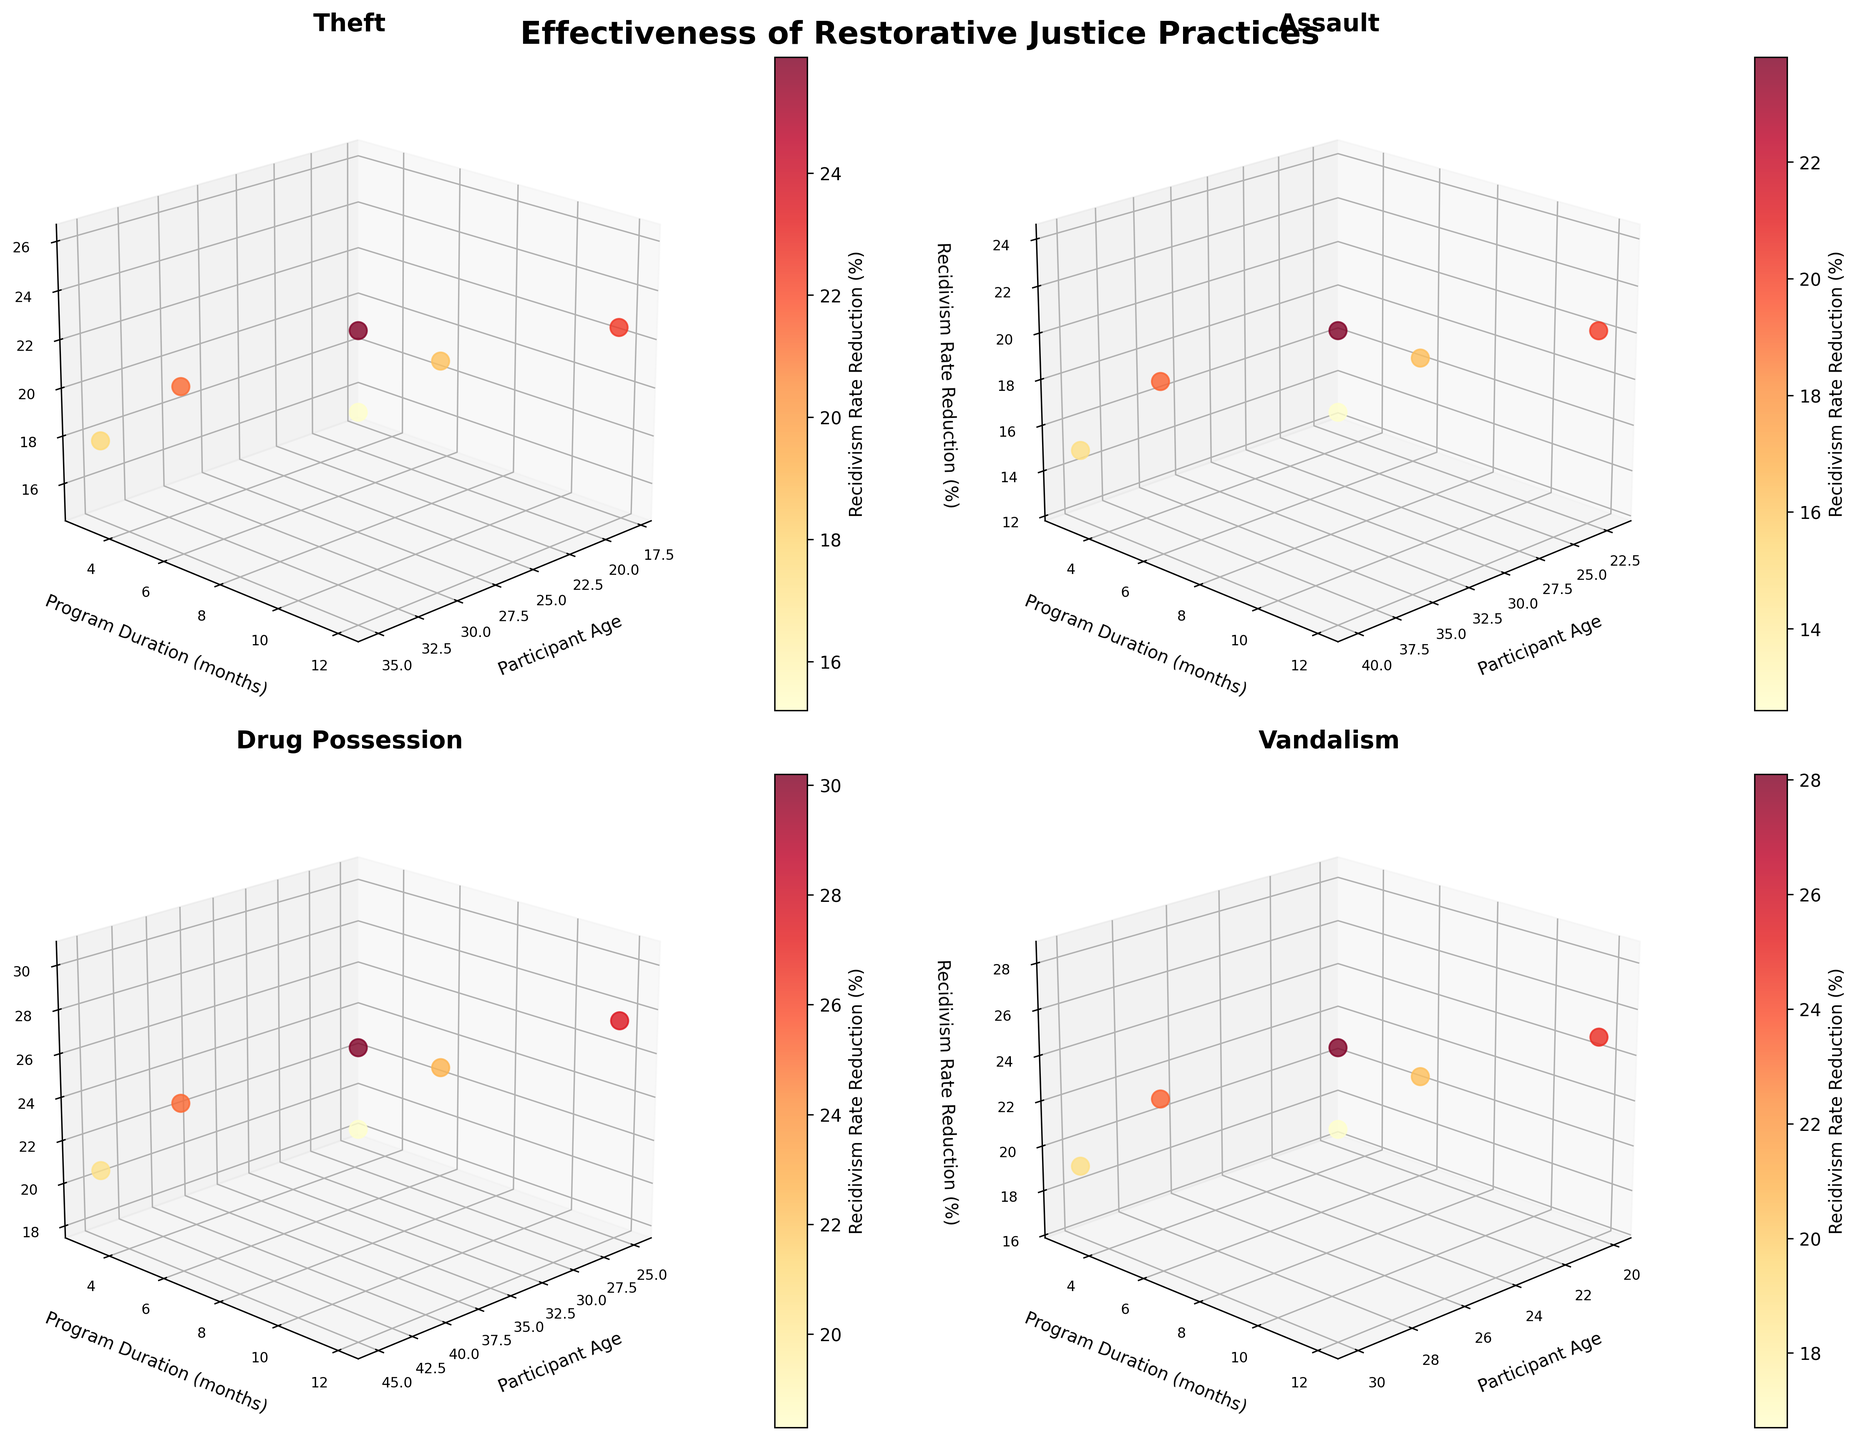How many offense types are presented in the figure? There are four subplots in the figure, each representing a different offense type. Counting these subplots gives us the total number of offense types.
Answer: Four What is the main title of the figure? The main title is located at the top of the entire figure. It is usually in bold and larger font than the individual subplot titles.
Answer: Effectiveness of Restorative Justice Practices Which participant age group shows the highest recidivism rate reduction for the "Drug Possession" offense? In the subplot titled "Drug Possession", locate the 3D scatter points, and find the participant age with the highest value on the z-axis (Recidivism Rate Reduction).
Answer: 45 Does the "Theft" offense show a greater recidivism rate reduction at 3 months or 12 months for a participant aged 18? In the subplot titled "Theft", look at the z-axis (Recidivism Rate Reduction) values for 18-year-old participants comparing 3 months and 12 months program durations.
Answer: 12 months What is the range of program durations shown in the figure? The y-axes (Program Duration in months) of all subplots collectively show the minimum and maximum program durations.
Answer: 3 to 12 months Which offense type shows the smallest reduction in recidivism rate at 6 months for participants in their 20s? For each subplot, locate the 3D scatter point for 6 months program duration and participant ages in the 20s. Compare the z-axis (Recidivism Rate Reduction) values and find the smallest one.
Answer: Assault Comparing "Theft" and "Vandalism", which offense has a higher recidivism rate reduction for a 35-year-old participant at 6 months? In the "Theft" and "Vandalism" subplots, find the 3D points for 35-year-old participants at 6 months program duration and compare the z-axis (Recidivism Rate Reduction) values.
Answer: Vandalism Is there a trend in recidivism reduction rate concerning program duration for the "Assault" offense? In the "Assault" subplot, observe the z-axis (Recidivism Rate Reduction) values across different program durations (x-axis). Notice if there is a consistent increase or decrease.
Answer: Increasing trend Which age group shows a more significant overall impact of program duration on reducing recidivism for the "Vandalism" offense? In the "Vandalism" subplot, compare the z-axis (Recidivism Rate Reduction) values across different program durations for 20-year-old and 30-year-old participants. The age group with more considerable differences has a more significant overall impact.
Answer: 30 year-olds 